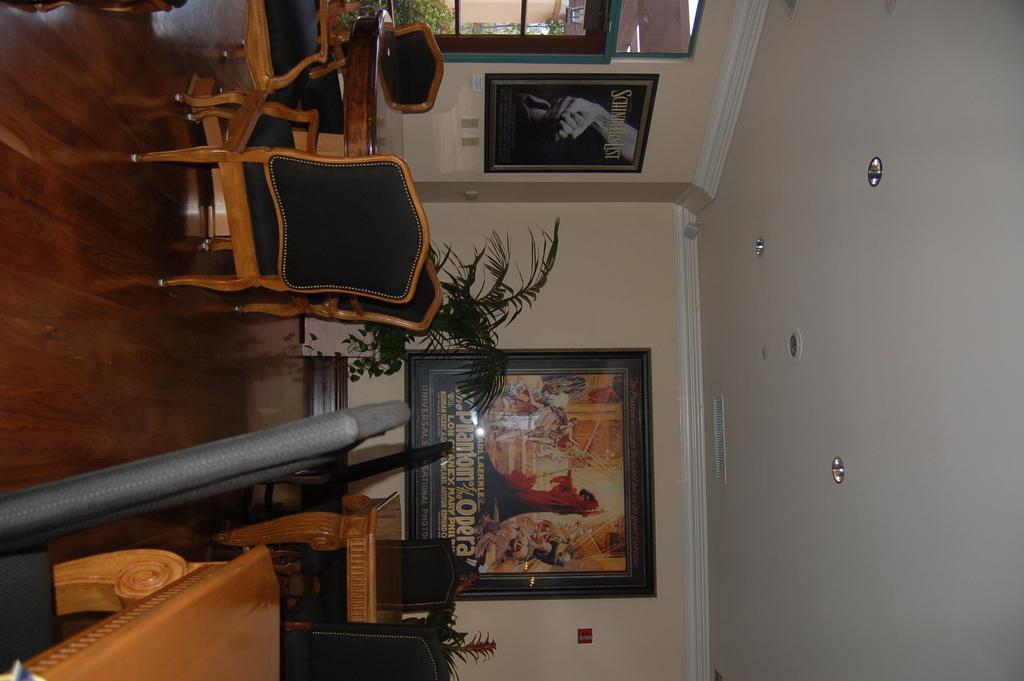What type of furniture is present in the image? There is a table and a chair in the image. Can you describe the frame in the background? There is a frame attached to the wall in the background. What type of object is used for holding plants in the image? There is a flower pot in the image. Where is the crate located in the image? There is no crate present in the image. What type of net can be seen in the image? There is no net present in the image. 